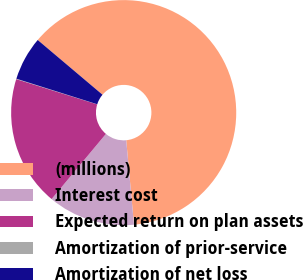<chart> <loc_0><loc_0><loc_500><loc_500><pie_chart><fcel>(millions)<fcel>Interest cost<fcel>Expected return on plan assets<fcel>Amortization of prior-service<fcel>Amortization of net loss<nl><fcel>62.37%<fcel>12.52%<fcel>18.75%<fcel>0.06%<fcel>6.29%<nl></chart> 